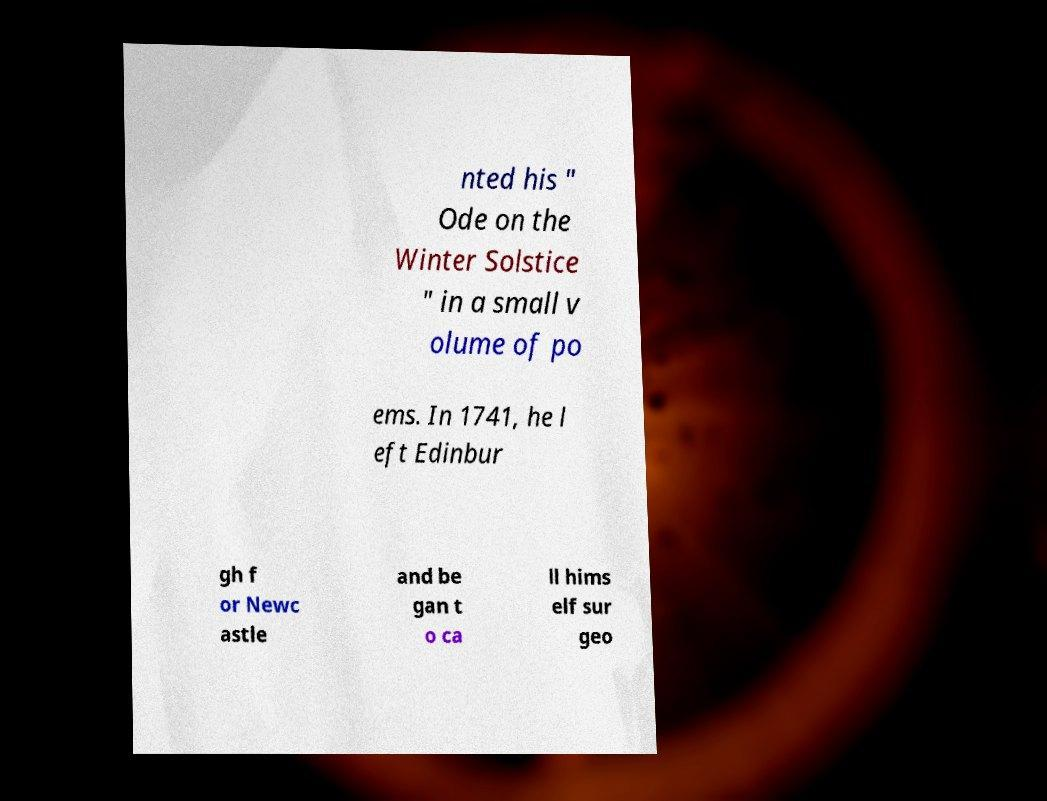Please read and relay the text visible in this image. What does it say? nted his " Ode on the Winter Solstice " in a small v olume of po ems. In 1741, he l eft Edinbur gh f or Newc astle and be gan t o ca ll hims elf sur geo 